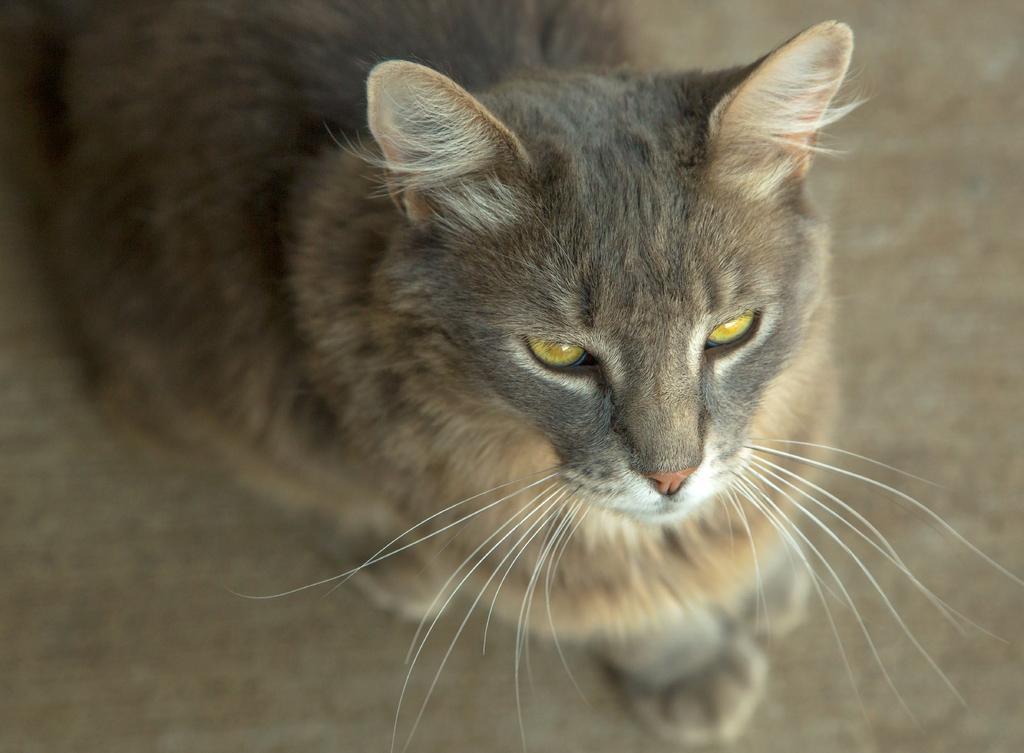In one or two sentences, can you explain what this image depicts? In this image we can see one cat sitting on the surface. 